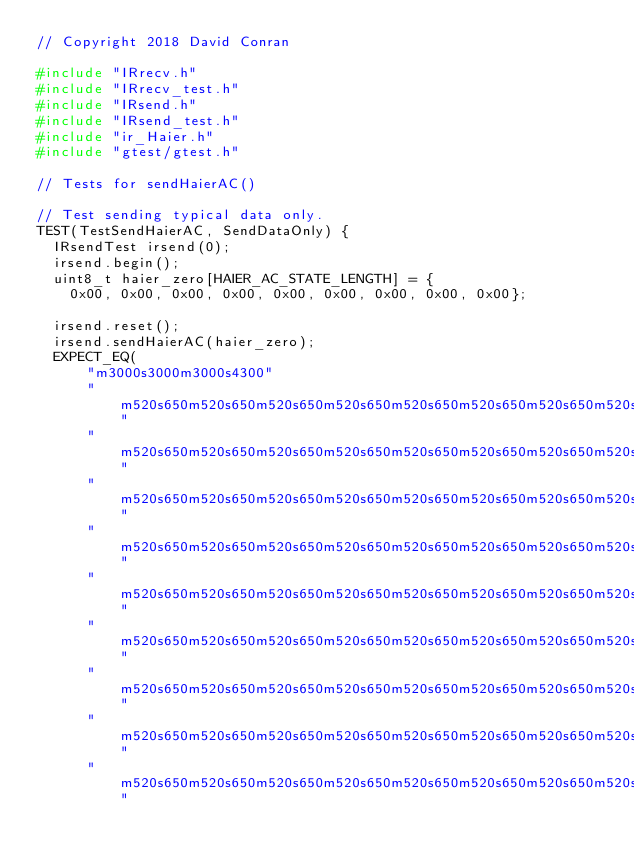Convert code to text. <code><loc_0><loc_0><loc_500><loc_500><_C++_>// Copyright 2018 David Conran

#include "IRrecv.h"
#include "IRrecv_test.h"
#include "IRsend.h"
#include "IRsend_test.h"
#include "ir_Haier.h"
#include "gtest/gtest.h"

// Tests for sendHaierAC()

// Test sending typical data only.
TEST(TestSendHaierAC, SendDataOnly) {
  IRsendTest irsend(0);
  irsend.begin();
  uint8_t haier_zero[HAIER_AC_STATE_LENGTH] = {
    0x00, 0x00, 0x00, 0x00, 0x00, 0x00, 0x00, 0x00, 0x00};

  irsend.reset();
  irsend.sendHaierAC(haier_zero);
  EXPECT_EQ(
      "m3000s3000m3000s4300"
      "m520s650m520s650m520s650m520s650m520s650m520s650m520s650m520s650"
      "m520s650m520s650m520s650m520s650m520s650m520s650m520s650m520s650"
      "m520s650m520s650m520s650m520s650m520s650m520s650m520s650m520s650"
      "m520s650m520s650m520s650m520s650m520s650m520s650m520s650m520s650"
      "m520s650m520s650m520s650m520s650m520s650m520s650m520s650m520s650"
      "m520s650m520s650m520s650m520s650m520s650m520s650m520s650m520s650"
      "m520s650m520s650m520s650m520s650m520s650m520s650m520s650m520s650"
      "m520s650m520s650m520s650m520s650m520s650m520s650m520s650m520s650"
      "m520s650m520s650m520s650m520s650m520s650m520s650m520s650m520s650"</code> 